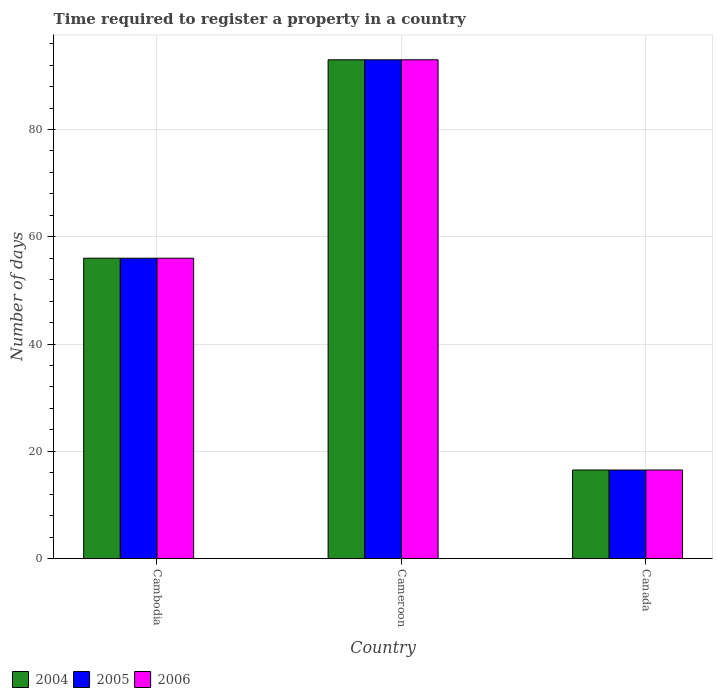How many different coloured bars are there?
Your answer should be very brief. 3. How many groups of bars are there?
Give a very brief answer. 3. Are the number of bars per tick equal to the number of legend labels?
Your answer should be compact. Yes. Are the number of bars on each tick of the X-axis equal?
Offer a terse response. Yes. How many bars are there on the 2nd tick from the left?
Your answer should be very brief. 3. What is the label of the 1st group of bars from the left?
Offer a very short reply. Cambodia. Across all countries, what is the maximum number of days required to register a property in 2005?
Make the answer very short. 93. Across all countries, what is the minimum number of days required to register a property in 2006?
Offer a terse response. 16.5. In which country was the number of days required to register a property in 2004 maximum?
Your answer should be very brief. Cameroon. What is the total number of days required to register a property in 2006 in the graph?
Offer a terse response. 165.5. What is the difference between the number of days required to register a property in 2005 in Cambodia and that in Canada?
Ensure brevity in your answer.  39.5. What is the difference between the number of days required to register a property in 2005 in Cambodia and the number of days required to register a property in 2004 in Cameroon?
Offer a very short reply. -37. What is the average number of days required to register a property in 2004 per country?
Provide a short and direct response. 55.17. In how many countries, is the number of days required to register a property in 2005 greater than 8 days?
Your answer should be very brief. 3. What is the ratio of the number of days required to register a property in 2006 in Cambodia to that in Canada?
Provide a short and direct response. 3.39. Is the number of days required to register a property in 2006 in Cambodia less than that in Canada?
Offer a terse response. No. Is the difference between the number of days required to register a property in 2005 in Cameroon and Canada greater than the difference between the number of days required to register a property in 2006 in Cameroon and Canada?
Your answer should be very brief. No. What is the difference between the highest and the second highest number of days required to register a property in 2005?
Keep it short and to the point. 39.5. What is the difference between the highest and the lowest number of days required to register a property in 2005?
Ensure brevity in your answer.  76.5. In how many countries, is the number of days required to register a property in 2006 greater than the average number of days required to register a property in 2006 taken over all countries?
Keep it short and to the point. 2. How many bars are there?
Keep it short and to the point. 9. Are all the bars in the graph horizontal?
Offer a very short reply. No. What is the difference between two consecutive major ticks on the Y-axis?
Provide a succinct answer. 20. How many legend labels are there?
Make the answer very short. 3. What is the title of the graph?
Keep it short and to the point. Time required to register a property in a country. Does "1961" appear as one of the legend labels in the graph?
Your answer should be compact. No. What is the label or title of the Y-axis?
Ensure brevity in your answer.  Number of days. What is the Number of days in 2004 in Cambodia?
Offer a very short reply. 56. What is the Number of days of 2006 in Cambodia?
Keep it short and to the point. 56. What is the Number of days in 2004 in Cameroon?
Your response must be concise. 93. What is the Number of days in 2005 in Cameroon?
Your answer should be compact. 93. What is the Number of days in 2006 in Cameroon?
Provide a succinct answer. 93. What is the Number of days in 2006 in Canada?
Make the answer very short. 16.5. Across all countries, what is the maximum Number of days of 2004?
Provide a short and direct response. 93. Across all countries, what is the maximum Number of days of 2005?
Your response must be concise. 93. Across all countries, what is the maximum Number of days of 2006?
Your response must be concise. 93. Across all countries, what is the minimum Number of days in 2006?
Offer a terse response. 16.5. What is the total Number of days of 2004 in the graph?
Make the answer very short. 165.5. What is the total Number of days of 2005 in the graph?
Ensure brevity in your answer.  165.5. What is the total Number of days of 2006 in the graph?
Make the answer very short. 165.5. What is the difference between the Number of days of 2004 in Cambodia and that in Cameroon?
Your answer should be compact. -37. What is the difference between the Number of days in 2005 in Cambodia and that in Cameroon?
Offer a very short reply. -37. What is the difference between the Number of days in 2006 in Cambodia and that in Cameroon?
Give a very brief answer. -37. What is the difference between the Number of days in 2004 in Cambodia and that in Canada?
Offer a very short reply. 39.5. What is the difference between the Number of days in 2005 in Cambodia and that in Canada?
Your answer should be compact. 39.5. What is the difference between the Number of days in 2006 in Cambodia and that in Canada?
Give a very brief answer. 39.5. What is the difference between the Number of days in 2004 in Cameroon and that in Canada?
Offer a very short reply. 76.5. What is the difference between the Number of days in 2005 in Cameroon and that in Canada?
Offer a terse response. 76.5. What is the difference between the Number of days of 2006 in Cameroon and that in Canada?
Your answer should be compact. 76.5. What is the difference between the Number of days of 2004 in Cambodia and the Number of days of 2005 in Cameroon?
Your response must be concise. -37. What is the difference between the Number of days in 2004 in Cambodia and the Number of days in 2006 in Cameroon?
Your response must be concise. -37. What is the difference between the Number of days in 2005 in Cambodia and the Number of days in 2006 in Cameroon?
Offer a terse response. -37. What is the difference between the Number of days of 2004 in Cambodia and the Number of days of 2005 in Canada?
Your answer should be compact. 39.5. What is the difference between the Number of days in 2004 in Cambodia and the Number of days in 2006 in Canada?
Your response must be concise. 39.5. What is the difference between the Number of days of 2005 in Cambodia and the Number of days of 2006 in Canada?
Offer a terse response. 39.5. What is the difference between the Number of days in 2004 in Cameroon and the Number of days in 2005 in Canada?
Keep it short and to the point. 76.5. What is the difference between the Number of days of 2004 in Cameroon and the Number of days of 2006 in Canada?
Provide a succinct answer. 76.5. What is the difference between the Number of days of 2005 in Cameroon and the Number of days of 2006 in Canada?
Provide a short and direct response. 76.5. What is the average Number of days in 2004 per country?
Your answer should be very brief. 55.17. What is the average Number of days of 2005 per country?
Keep it short and to the point. 55.17. What is the average Number of days in 2006 per country?
Offer a very short reply. 55.17. What is the difference between the Number of days in 2004 and Number of days in 2005 in Cambodia?
Give a very brief answer. 0. What is the difference between the Number of days of 2005 and Number of days of 2006 in Cameroon?
Your response must be concise. 0. What is the difference between the Number of days of 2005 and Number of days of 2006 in Canada?
Ensure brevity in your answer.  0. What is the ratio of the Number of days in 2004 in Cambodia to that in Cameroon?
Provide a succinct answer. 0.6. What is the ratio of the Number of days in 2005 in Cambodia to that in Cameroon?
Provide a short and direct response. 0.6. What is the ratio of the Number of days in 2006 in Cambodia to that in Cameroon?
Keep it short and to the point. 0.6. What is the ratio of the Number of days of 2004 in Cambodia to that in Canada?
Make the answer very short. 3.39. What is the ratio of the Number of days of 2005 in Cambodia to that in Canada?
Ensure brevity in your answer.  3.39. What is the ratio of the Number of days of 2006 in Cambodia to that in Canada?
Ensure brevity in your answer.  3.39. What is the ratio of the Number of days of 2004 in Cameroon to that in Canada?
Provide a succinct answer. 5.64. What is the ratio of the Number of days of 2005 in Cameroon to that in Canada?
Provide a succinct answer. 5.64. What is the ratio of the Number of days of 2006 in Cameroon to that in Canada?
Provide a short and direct response. 5.64. What is the difference between the highest and the lowest Number of days of 2004?
Keep it short and to the point. 76.5. What is the difference between the highest and the lowest Number of days in 2005?
Your response must be concise. 76.5. What is the difference between the highest and the lowest Number of days in 2006?
Provide a short and direct response. 76.5. 